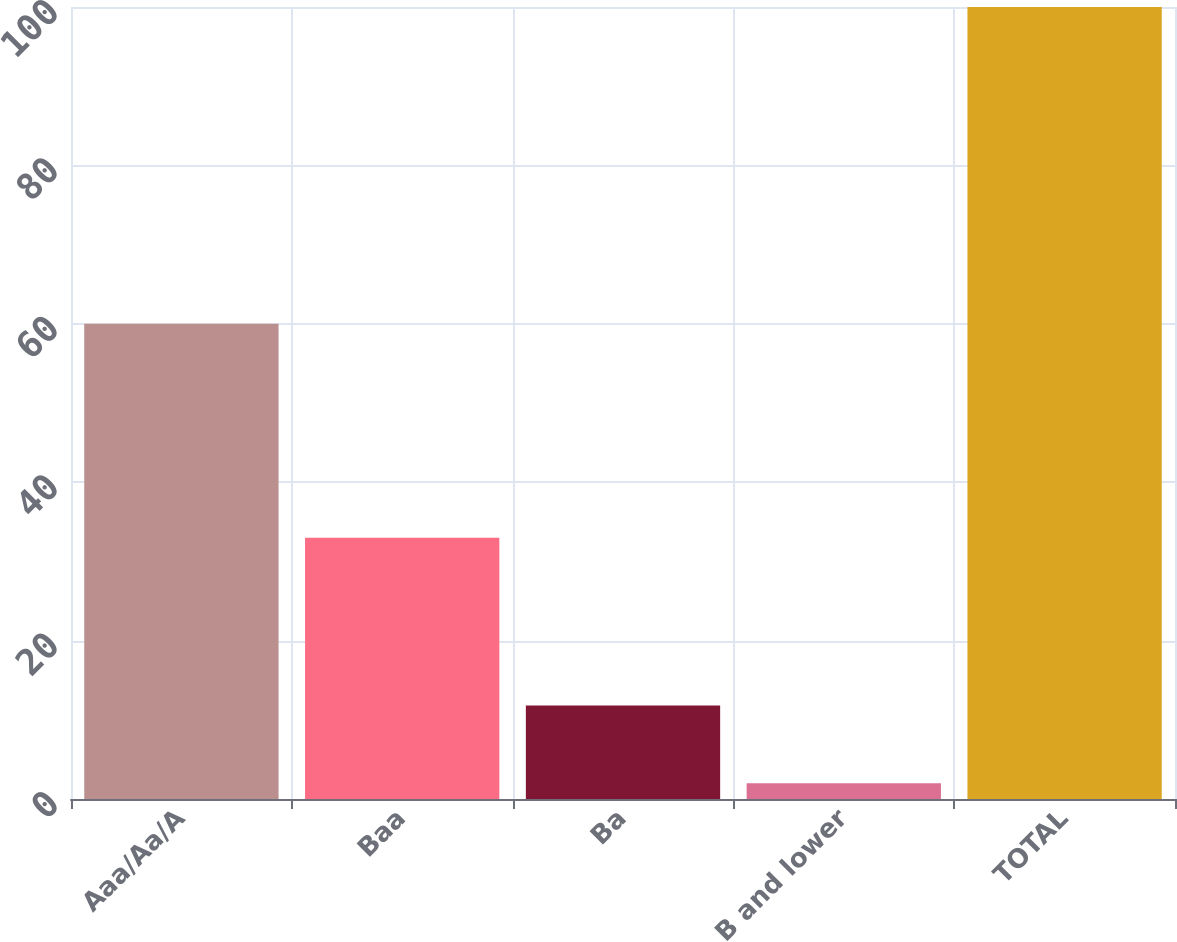<chart> <loc_0><loc_0><loc_500><loc_500><bar_chart><fcel>Aaa/Aa/A<fcel>Baa<fcel>Ba<fcel>B and lower<fcel>TOTAL<nl><fcel>60<fcel>33<fcel>11.8<fcel>2<fcel>100<nl></chart> 